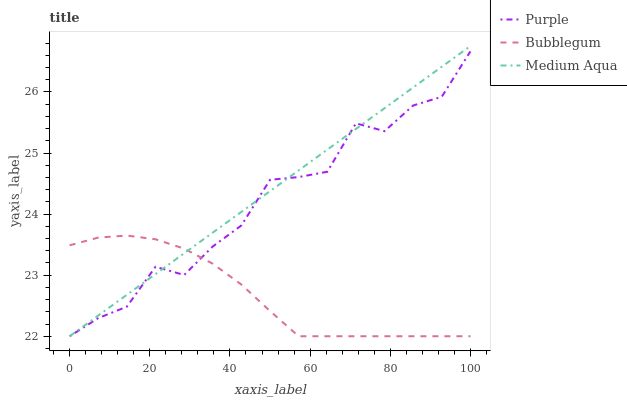Does Bubblegum have the minimum area under the curve?
Answer yes or no. Yes. Does Medium Aqua have the maximum area under the curve?
Answer yes or no. Yes. Does Medium Aqua have the minimum area under the curve?
Answer yes or no. No. Does Bubblegum have the maximum area under the curve?
Answer yes or no. No. Is Medium Aqua the smoothest?
Answer yes or no. Yes. Is Purple the roughest?
Answer yes or no. Yes. Is Bubblegum the smoothest?
Answer yes or no. No. Is Bubblegum the roughest?
Answer yes or no. No. Does Purple have the lowest value?
Answer yes or no. Yes. Does Medium Aqua have the highest value?
Answer yes or no. Yes. Does Bubblegum have the highest value?
Answer yes or no. No. Does Medium Aqua intersect Purple?
Answer yes or no. Yes. Is Medium Aqua less than Purple?
Answer yes or no. No. Is Medium Aqua greater than Purple?
Answer yes or no. No. 